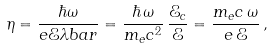Convert formula to latex. <formula><loc_0><loc_0><loc_500><loc_500>\eta = \frac { \hbar { \omega } } { e { \mathcal { E } } \lambda b a r } = \frac { \hbar { \, } \omega } { m _ { e } c ^ { 2 } } \, \frac { { \mathcal { E } } _ { c } } { \mathcal { E } } = \frac { m _ { e } c \, \omega } { e \, \mathcal { E } } \, ,</formula> 